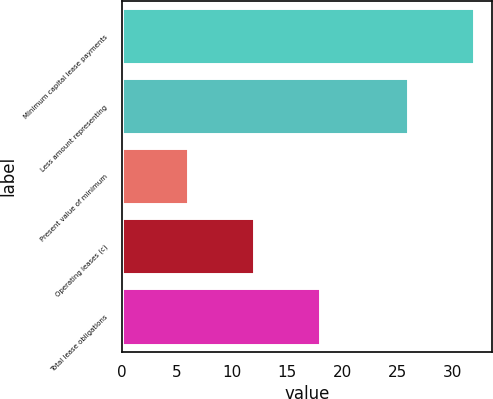Convert chart. <chart><loc_0><loc_0><loc_500><loc_500><bar_chart><fcel>Minimum capital lease payments<fcel>Less amount representing<fcel>Present value of minimum<fcel>Operating leases (c)<fcel>Total lease obligations<nl><fcel>32<fcel>26<fcel>6<fcel>12<fcel>18<nl></chart> 